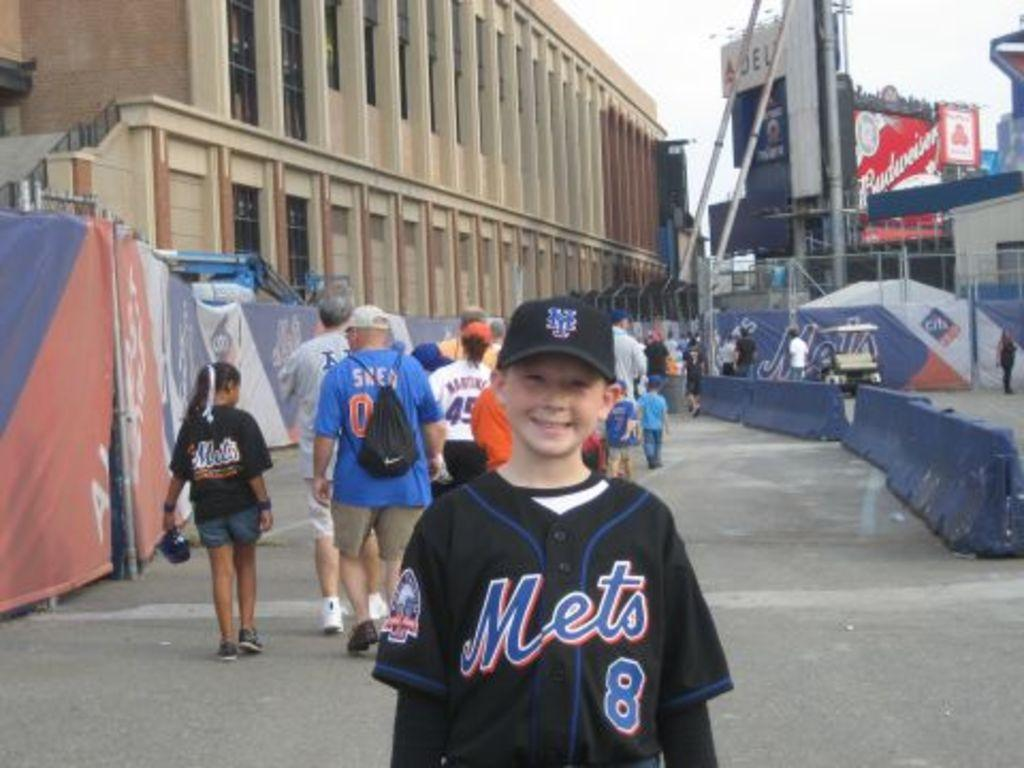<image>
Create a compact narrative representing the image presented. A young boy wearing a Mets jersey is posing outside near a large building. 